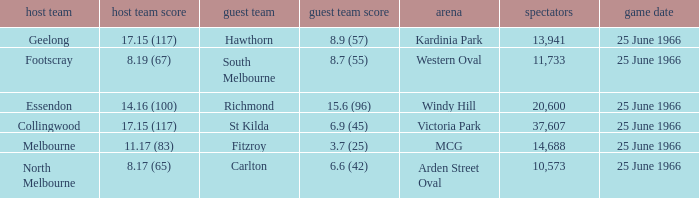When a home team scored 1 St Kilda. 